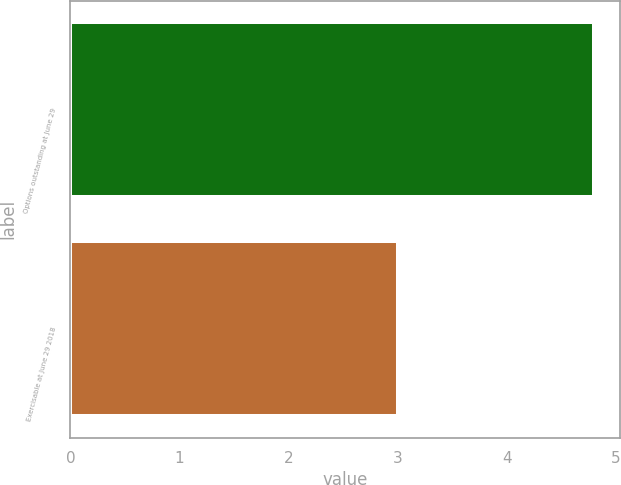Convert chart. <chart><loc_0><loc_0><loc_500><loc_500><bar_chart><fcel>Options outstanding at June 29<fcel>Exercisable at June 29 2018<nl><fcel>4.8<fcel>3<nl></chart> 